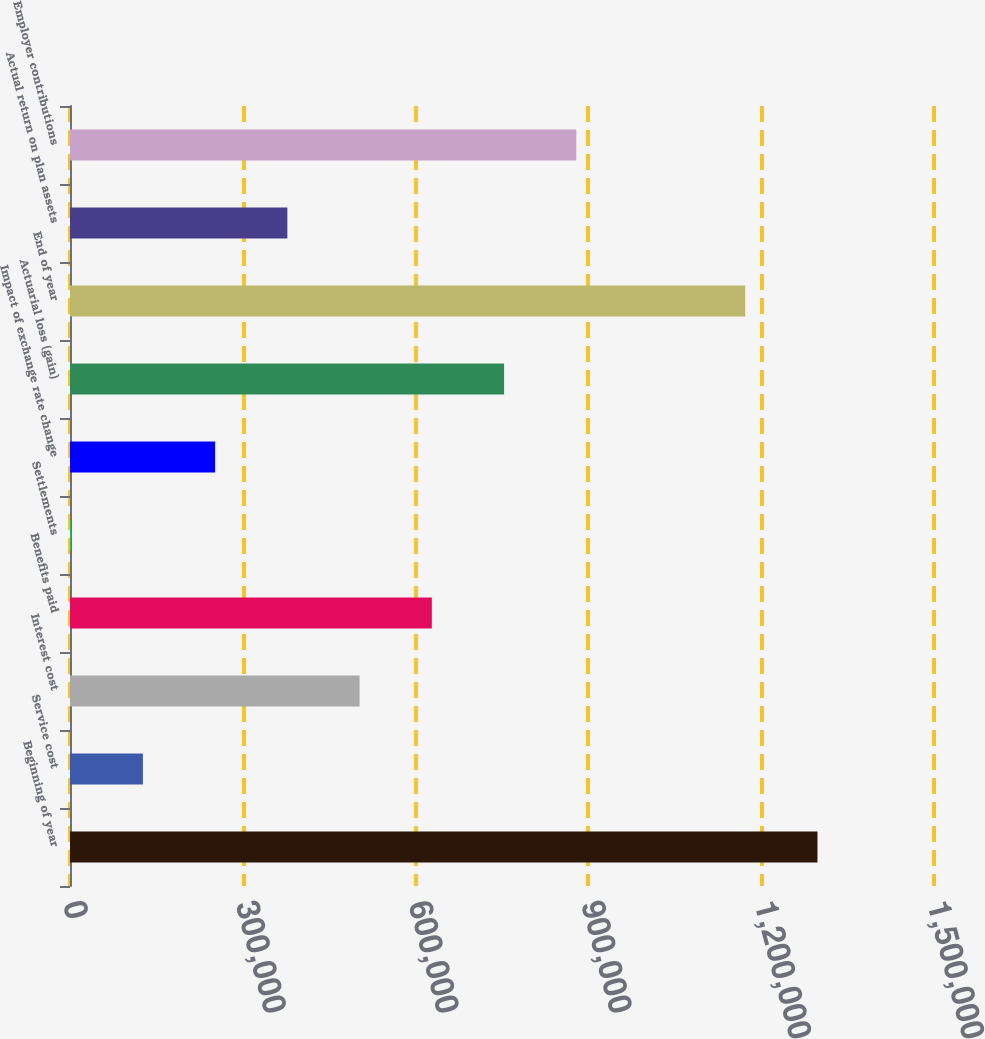Convert chart to OTSL. <chart><loc_0><loc_0><loc_500><loc_500><bar_chart><fcel>Beginning of year<fcel>Service cost<fcel>Interest cost<fcel>Benefits paid<fcel>Settlements<fcel>Impact of exchange rate change<fcel>Actuarial loss (gain)<fcel>End of year<fcel>Actual return on plan assets<fcel>Employer contributions<nl><fcel>1.29767e+06<fcel>126554<fcel>502775<fcel>628182<fcel>1147<fcel>251961<fcel>753588<fcel>1.17227e+06<fcel>377368<fcel>878995<nl></chart> 